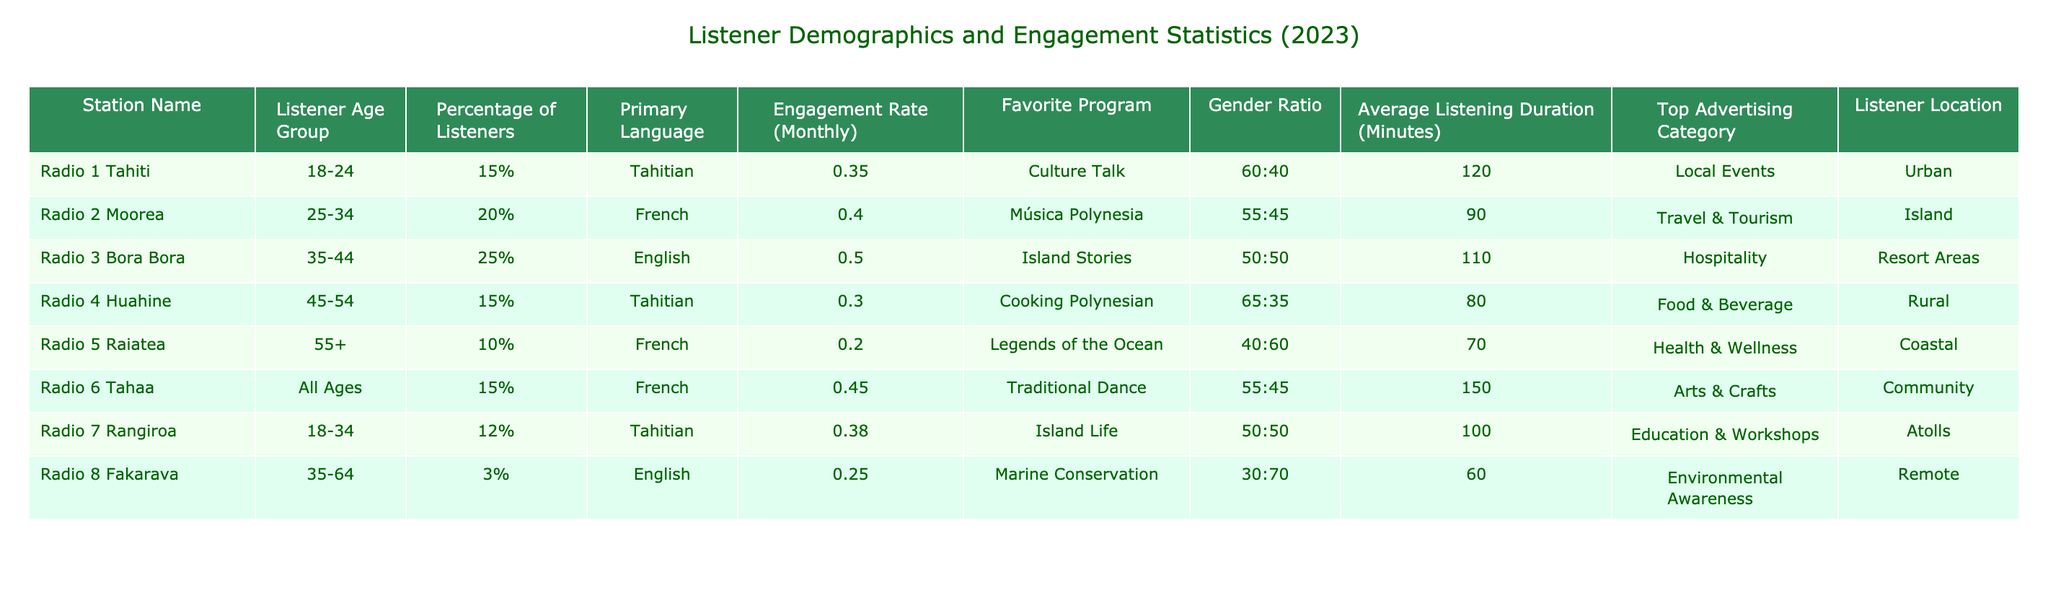What is the primary language of listeners for Radio 1 Tahiti? Looking at the row for Radio 1 Tahiti, the primary language listed is Tahitian.
Answer: Tahitian Which radio station has the highest engagement rate? By reviewing the engagement rates in the table, Radio 3 Bora Bora has the highest engagement rate of 0.50.
Answer: Radio 3 Bora Bora What percentage of listeners are aged 35-44 for Radio 3 Bora Bora? The table indicates that for Radio 3 Bora Bora, the listener age group 35-44 makes up 25% of the audience.
Answer: 25% Is the listener gender ratio for Radio 4 Huahine skewed more towards males or females? The gender ratio for Radio 4 Huahine is 65:35, which indicates a skew towards males.
Answer: Yes Which program has the longest average listening duration across all stations? Reviewing the average listening durations, Radio 6 Tahaa's program has the longest average listening duration at 150 minutes.
Answer: Traditional Dance How many listeners aged 25-34 did Radio 2 Moorea have compared to those aged 55+ from Radio 5 Raiatea? Radio 2 Moorea has 20% of listeners aged 25-34, while Radio 5 Raiatea has 10% of listeners aged 55+. Thus, there are more listeners aged 25-34 than those aged 55+.
Answer: Yes What is the average engagement rate for all stations? First, sum the engagement rates (0.35 + 0.40 + 0.50 + 0.30 + 0.20 + 0.45 + 0.38 + 0.25) = 2.63. Since there are 8 stations, the average is 2.63/8 = 0.32875.
Answer: Approximately 0.33 Which advertisement category is most commonly favored among listeners overall? The advertisement categories from the table include Local Events, Travel & Tourism, Hospitality, Food & Beverage, Health & Wellness, Arts & Crafts, Education & Workshops, and Environmental Awareness. The most common ones are Local Events and Travel & Tourism based on the presence in the data.
Answer: Local Events How does the listener percentage for Radio 8 Fakarava compare to that of Radio 6 Tahaa? Radio 8 Fakarava has 3% of listeners while Radio 6 Tahaa has 15%. Therefore, Radio 6 Tahaa has a significantly higher percentage of listeners.
Answer: Yes What can be inferred about the locations of listeners for Radio stations in remote and urban areas? Checking the table, Radio 6 Tahaa, located in the community, has an average listening duration of 150 minutes with an engagement rate of 0.45, while Radio 4 Huahine in rural areas has a lower engagement rate of 0.30 and shorter duration. This suggests urban listeners may engage more with the radio.
Answer: Yes 